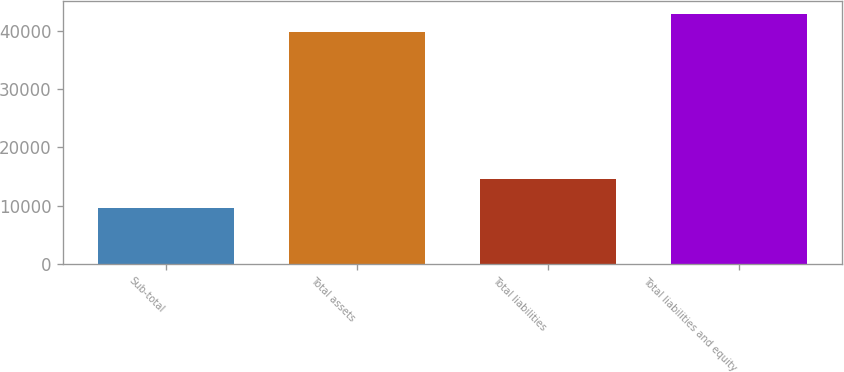<chart> <loc_0><loc_0><loc_500><loc_500><bar_chart><fcel>Sub-total<fcel>Total assets<fcel>Total liabilities<fcel>Total liabilities and equity<nl><fcel>9537<fcel>39849<fcel>14475<fcel>42880.2<nl></chart> 